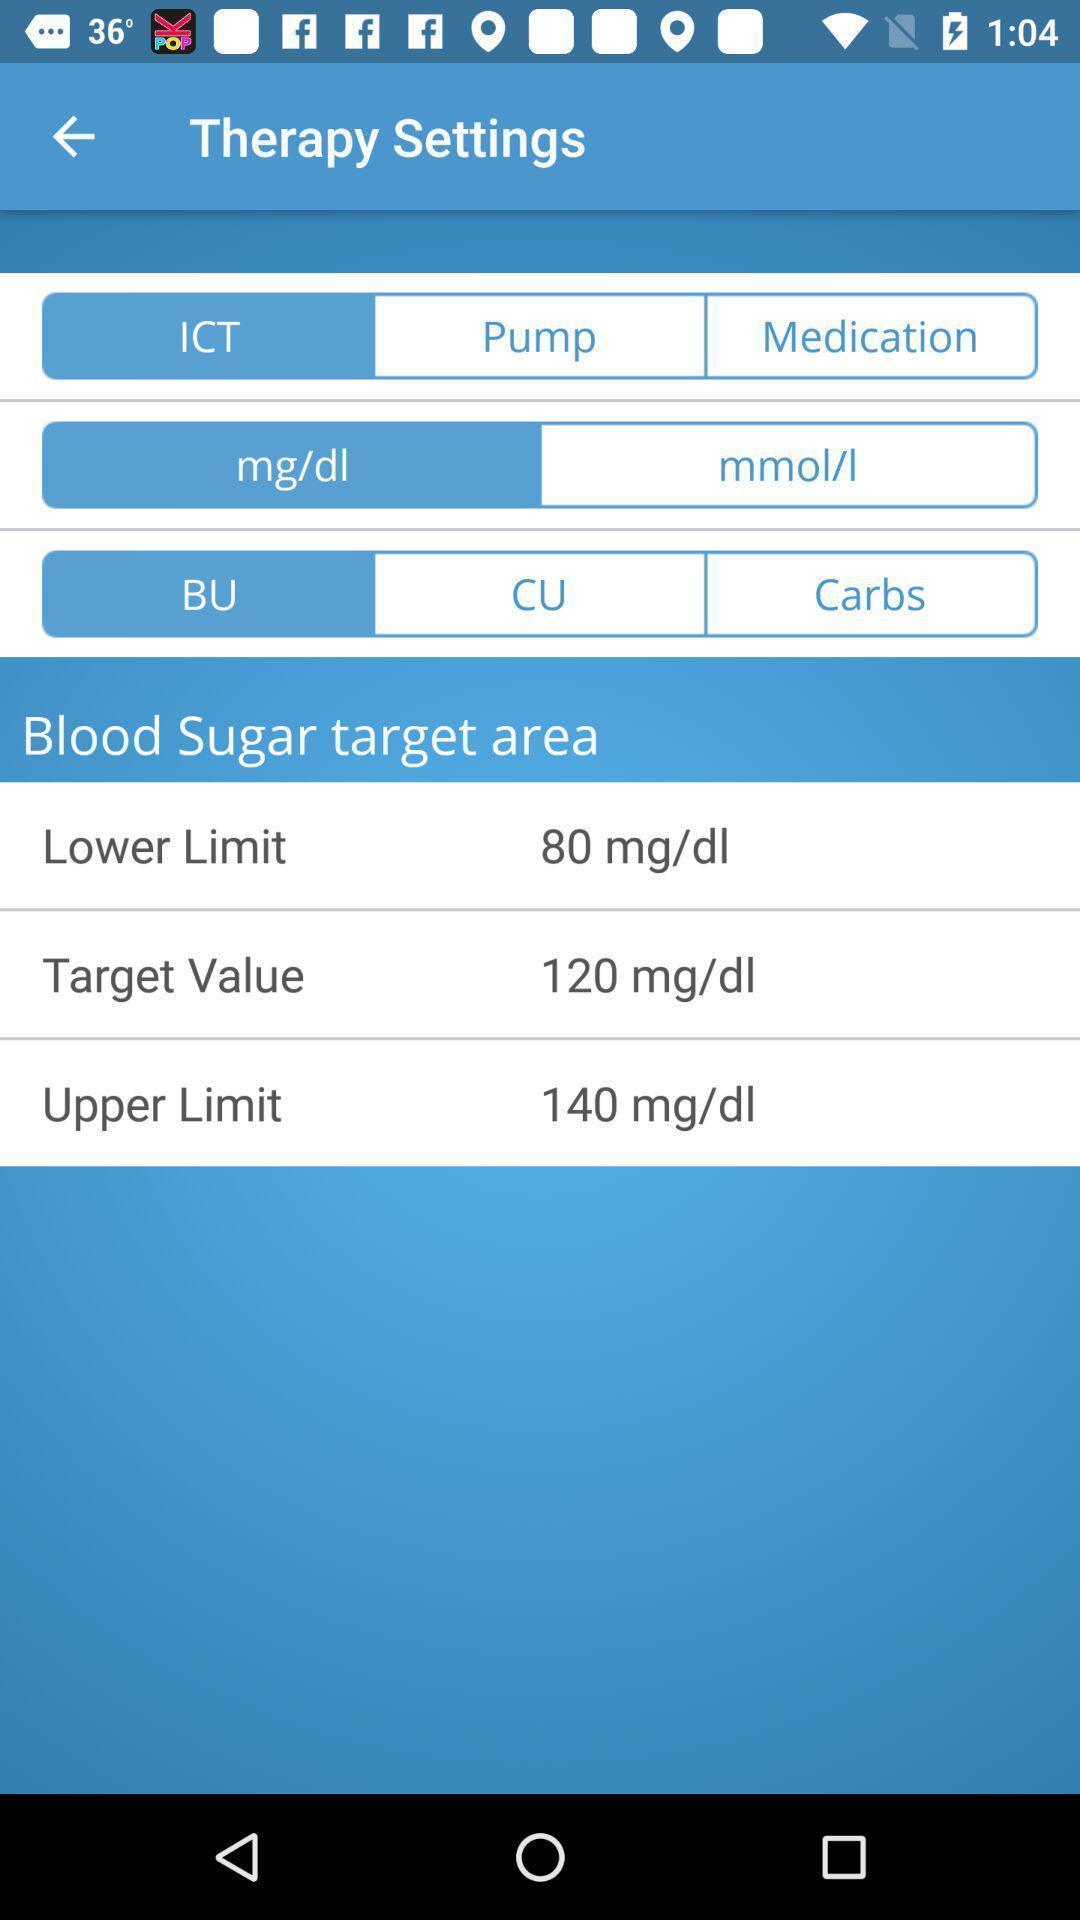Describe the visual elements of this screenshot. Settings page of a health application. 